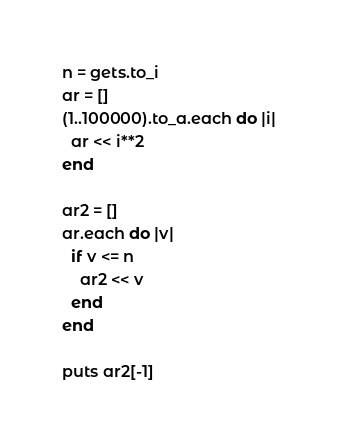<code> <loc_0><loc_0><loc_500><loc_500><_Ruby_>n = gets.to_i
ar = []
(1..100000).to_a.each do |i|
  ar << i**2
end

ar2 = []
ar.each do |v|
  if v <= n
    ar2 << v
  end
end

puts ar2[-1]</code> 